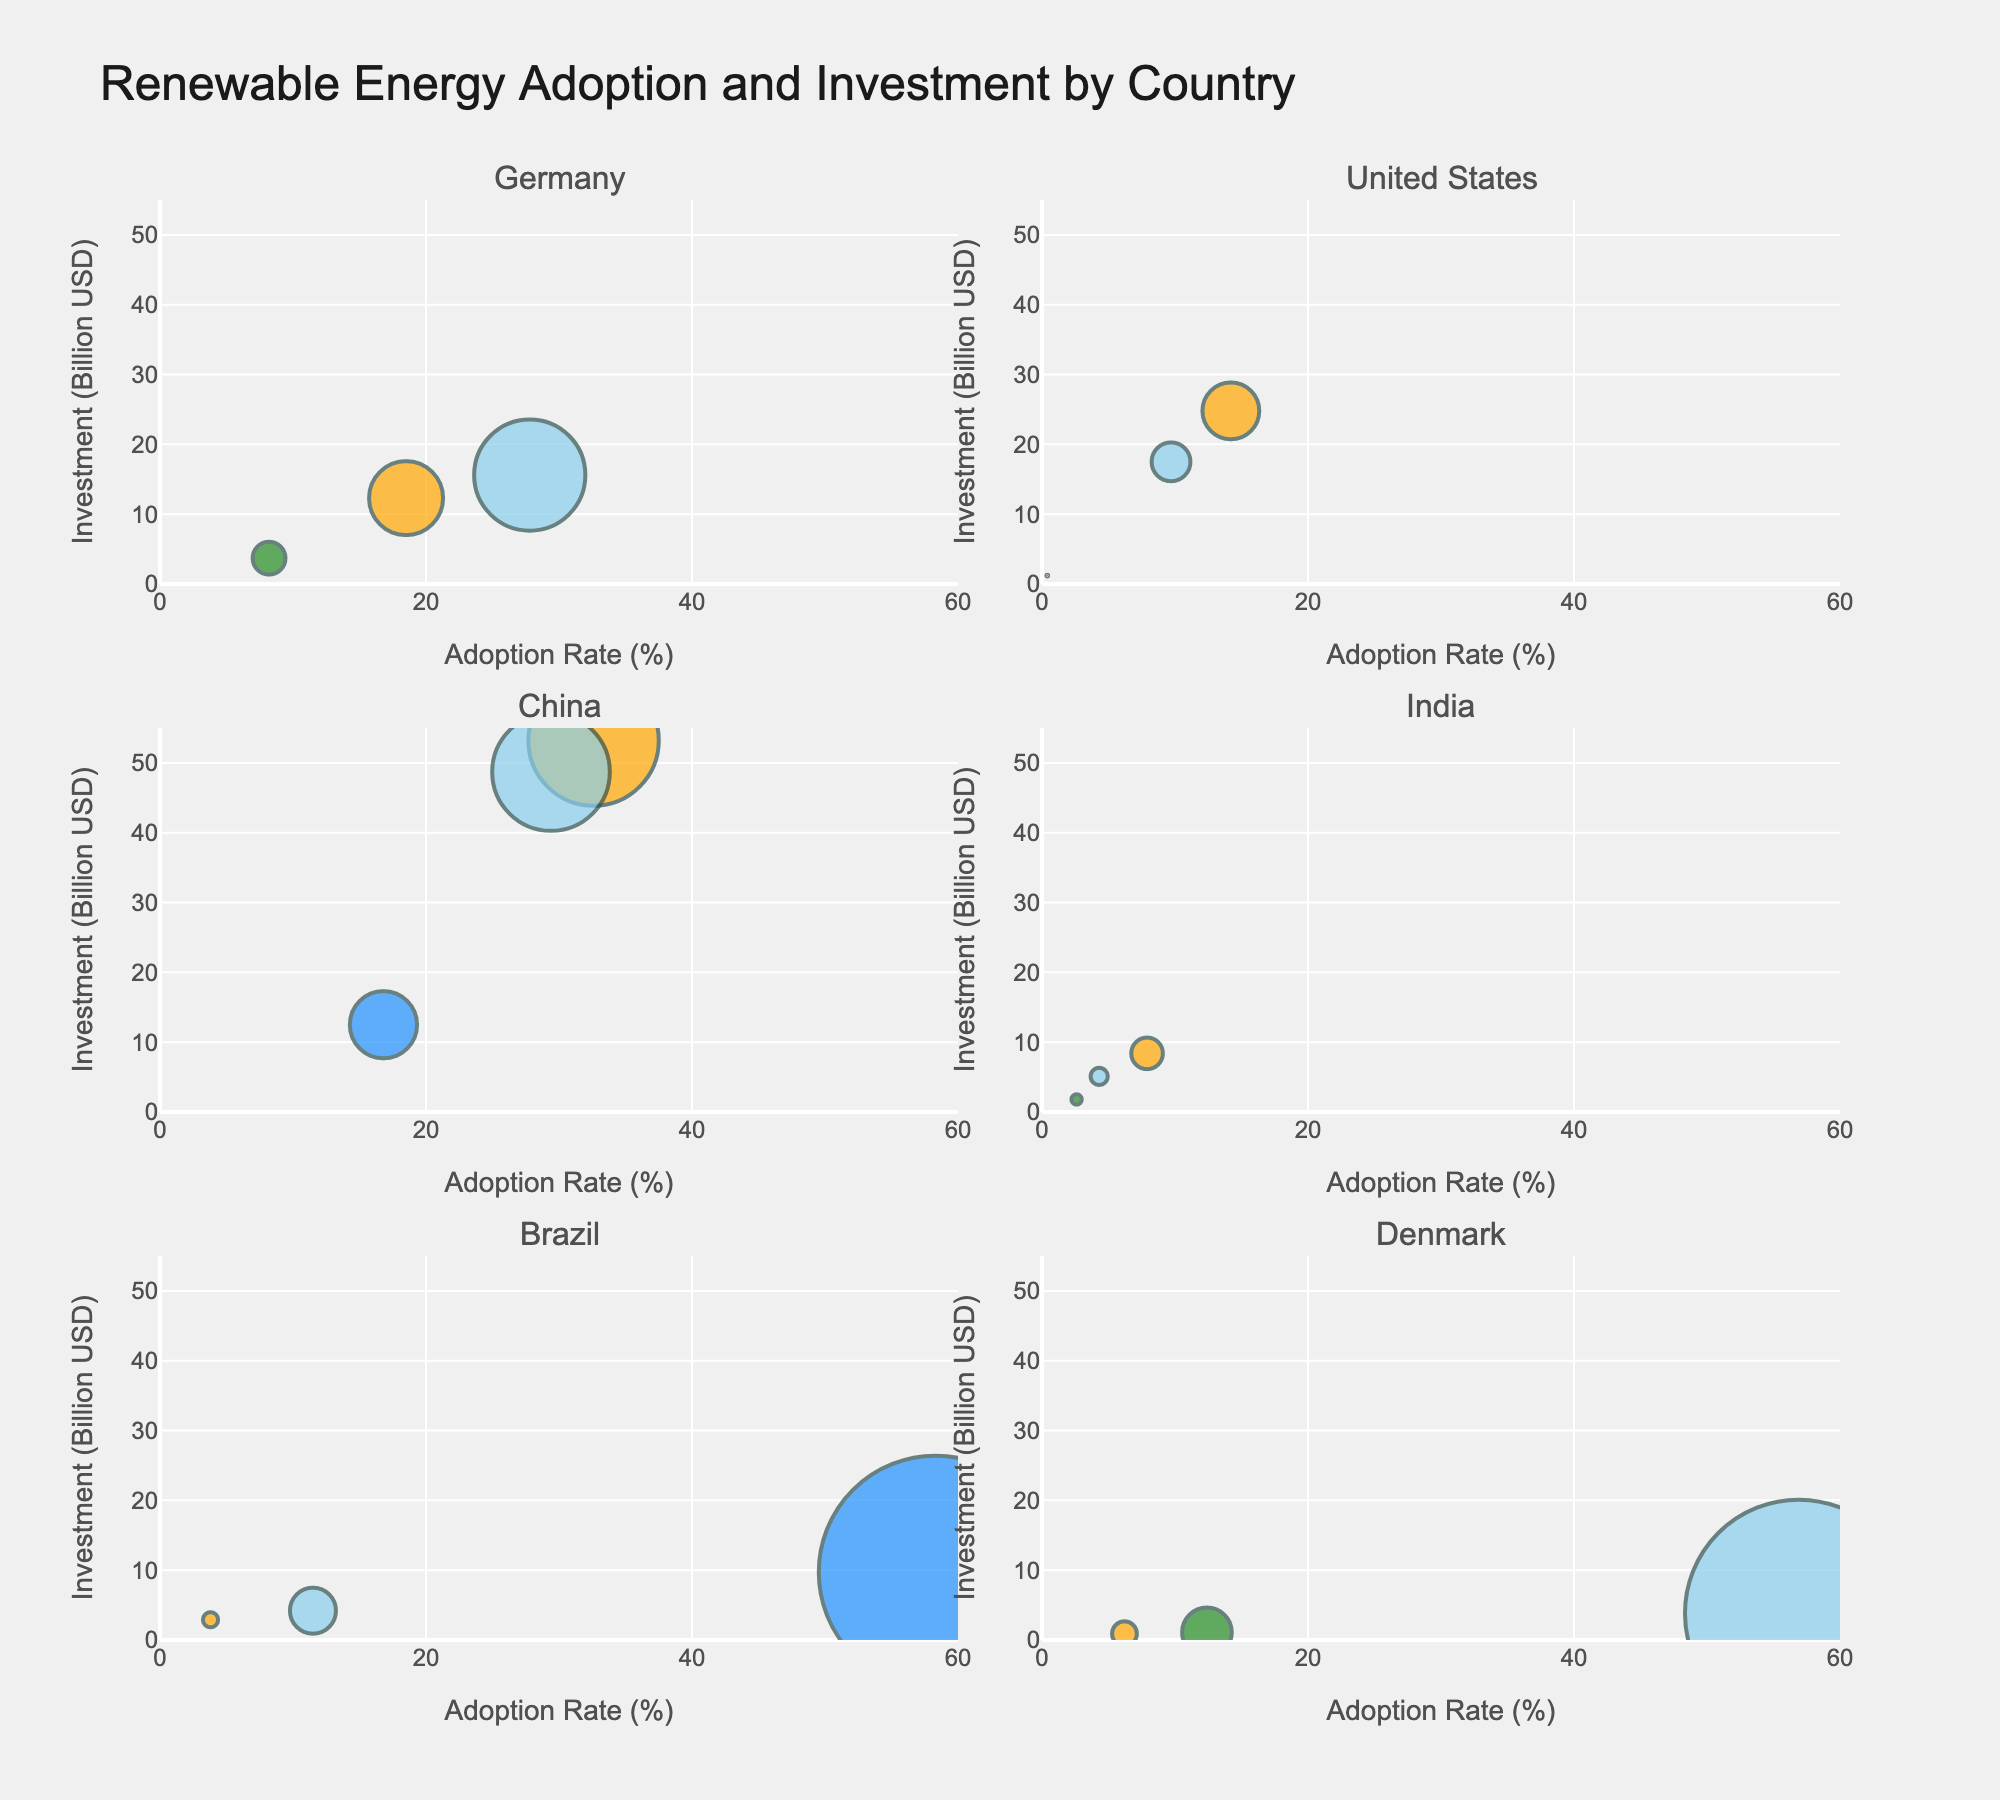How many countries display data in the figure? Each subplot is titled with a country name, and there are different subplot titles. By counting these subplot titles, we find there are six countries.
Answer: Six What technology has the highest adoption rate in China? The bubble chart for China shows several technologies, and the text information in each bubble displays the adoption rate. By comparing, we see Solar has the highest adoption rate of 32.6%.
Answer: Solar What's the total investment in Wind energy across all countries? By adding the investment values of Wind energy in each country from their bubbles: Germany (15.6B), US (17.5B), China (48.7B), India (5.1B), Brazil (4.2B), Denmark (3.8B). The total is 94.9B USD.
Answer: 94.9B USD Compare the Solar adoption rates between Germany and India. Which country has a higher rate? The adoption rate for Solar in Germany is 18.5%, while in India it’s 7.9%. Germany has a higher rate.
Answer: Germany Which country has the largest bubble for Wind technology and why? The size of the bubbles represents the adoption rate. By checking, the largest bubble for Wind is for China with an adoption rate of 29.4%, making its bubble bigger.
Answer: China What is the combined adoption rate of all renewable technologies in Brazil? In Brazil's subplot, the adoption rates are Solar 3.8%, Wind 11.5%, Hydropower 58.3%. Summing these rates gives a total of 73.6%.
Answer: 73.6% What's the smallest investment in renewable technologies by any country? By examining all subplot bubbles and their hover info, the smallest investment is Denmark's Solar technology, with 0.9B USD.
Answer: 0.9B USD Which country has the highest investment in Geothermal technology? Only the United States displays a bubble for Geothermal with an investment of 1.2B USD.
Answer: United States How does the Hydropower adoption rate in China compare to that in Brazil? The adoption rate for Hydropower in China is 16.8%, whereas in Brazil it is 58.3%. Brazil has a substantially higher rate.
Answer: Brazil 